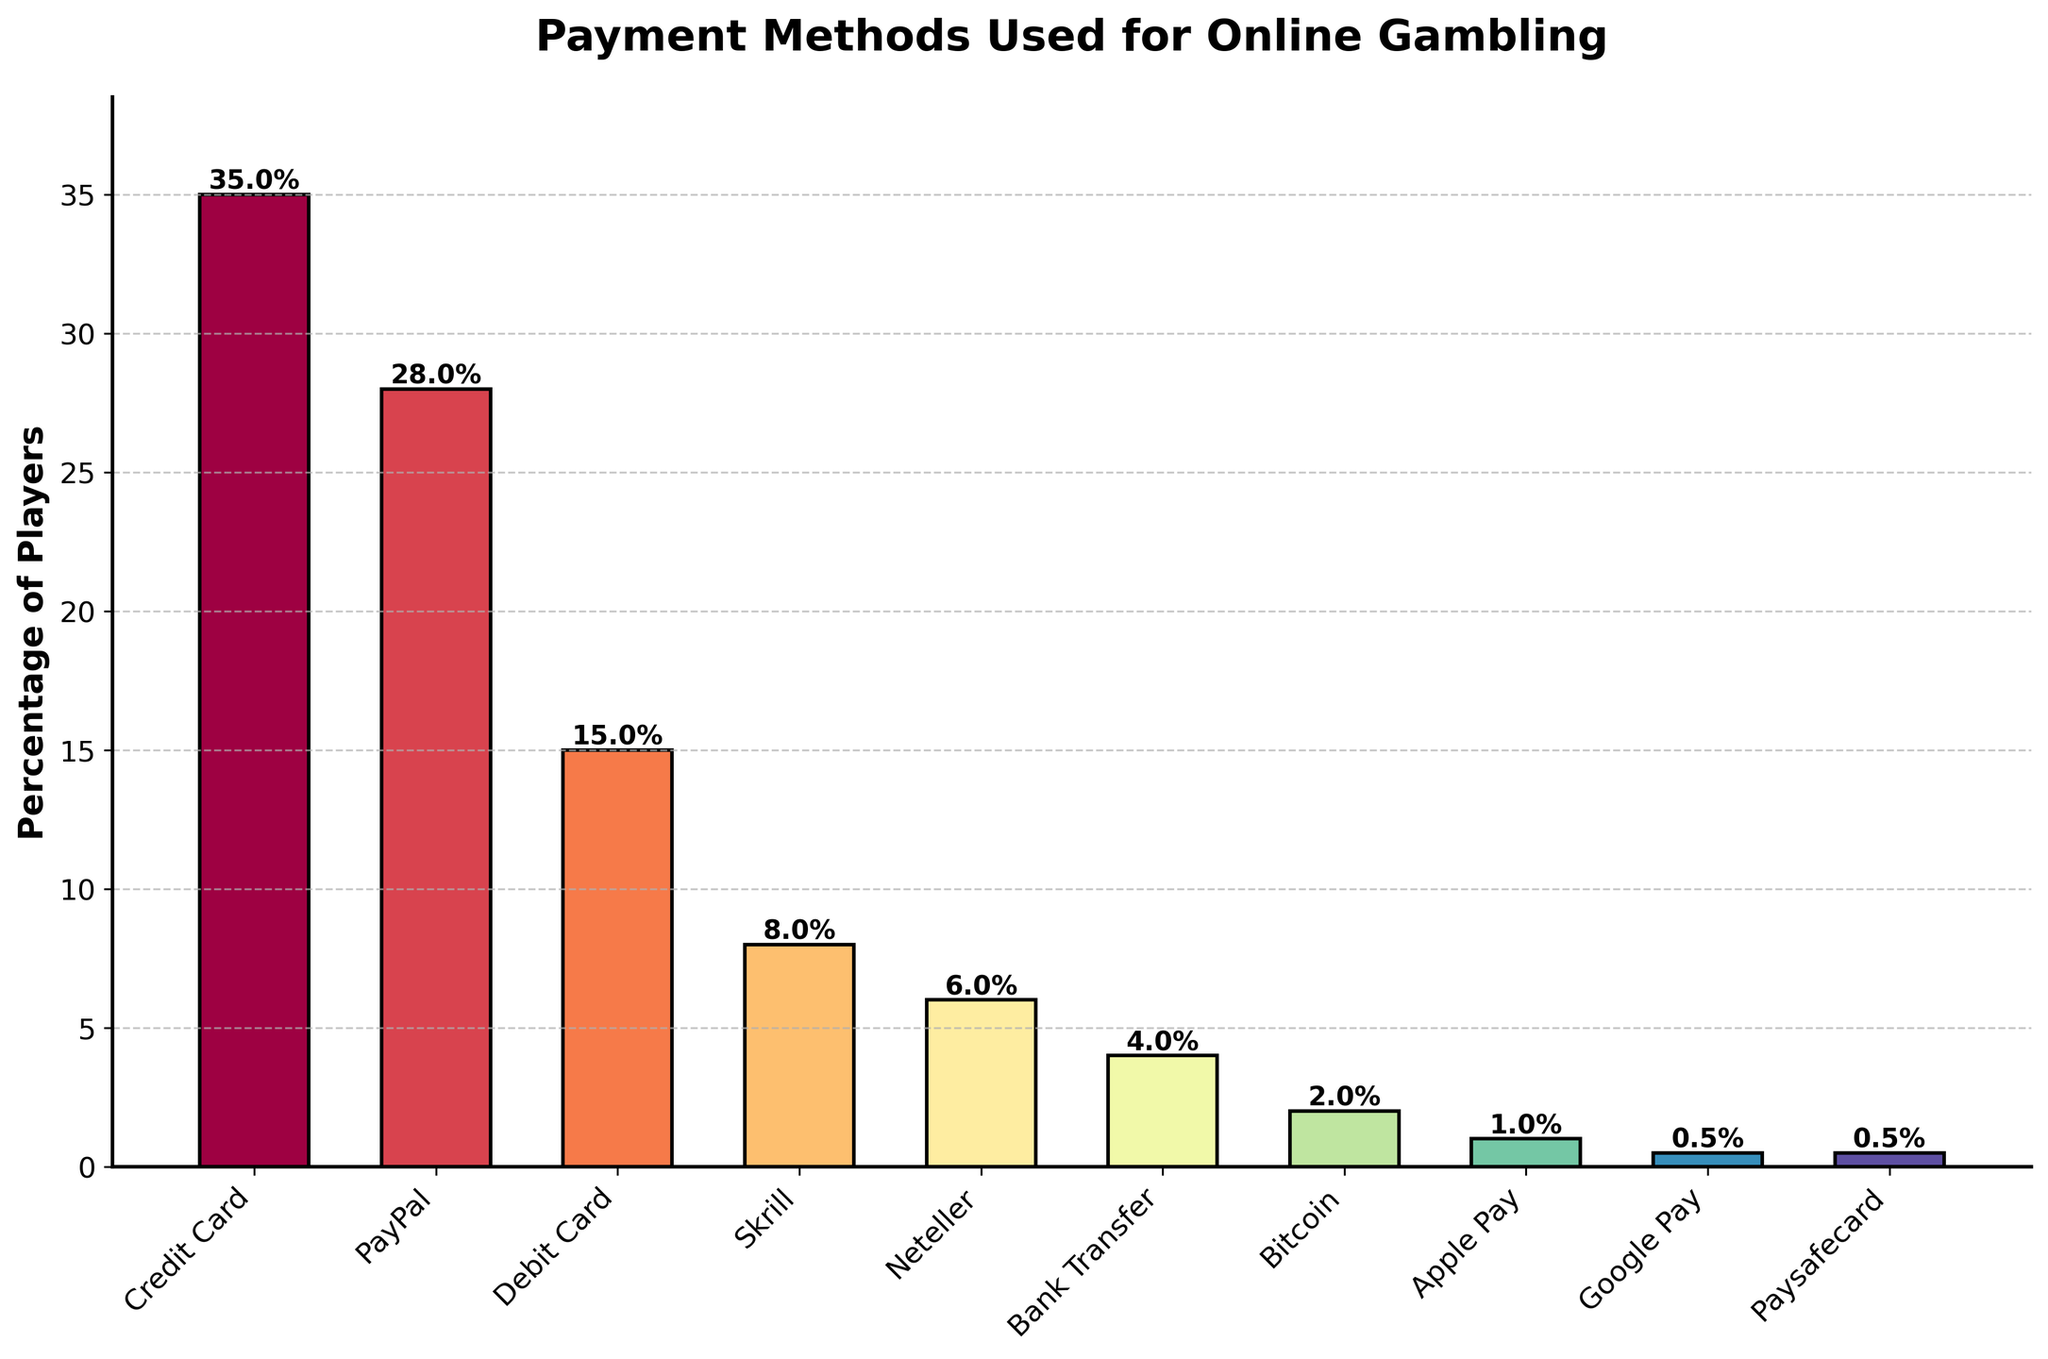What's the most popular payment method for online gambling? The bar for "Credit Card" is the tallest in the chart, with a percentage of 35%.
Answer: Credit Card Which payment method is used the least by players? From the bar chart, both "Google Pay" and "Paysafecard" have the smallest bars, each at 0.5%.
Answer: Google Pay and Paysafecard What percentage of players use PayPal for online gambling? The height of the PayPal bar represents 28%.
Answer: 28% How many payment methods have a usage percentage of 5% or more? By counting the bars with heights representing 5% or more: Credit Card, PayPal, Debit Card, Skrill, Neteller. There are five.
Answer: 5 How much more popular is using a Credit Card compared to a Debit Card? The percentage for Credit Card is 35%, and for Debit Card, it is 15%. The difference is 35% - 15% = 20%.
Answer: 20% What is the combined percentage of players using Skrill and Neteller? The percentage for Skrill is 8%, and for Neteller, it is 6%. The combined usage is 8% + 6% = 14%.
Answer: 14% Which payment method has a percentage closest to the average percentage of all the payment methods? First, compute the average: (35 + 28 + 15 + 8 + 6 + 4 + 2 + 1 + 0.5 + 0.5) / 10 = 10%. The payment method closest to 10% is Skrill with 8%.
Answer: Skrill List all the payment methods that are used by less than 10% of players. From the bar chart, the methods with percentages less than 10% are Skrill, Neteller, Bank Transfer, Bitcoin, Apple Pay, Google Pay, and Paysafecard.
Answer: Skrill, Neteller, Bank Transfer, Bitcoin, Apple Pay, Google Pay, Paysafecard Between PayPal and Skrill, which is more popular and by how much? The percentage for PayPal is 28%, and for Skrill, it is 8%. PayPal is more popular by 28% - 8% = 20%.
Answer: PayPal by 20% What is the total percentage of players who use either Bitcoin or Apple Pay? The percentage for Bitcoin is 2% and for Apple Pay, it is 1%. The total percentage is 2% + 1% = 3%.
Answer: 3% 